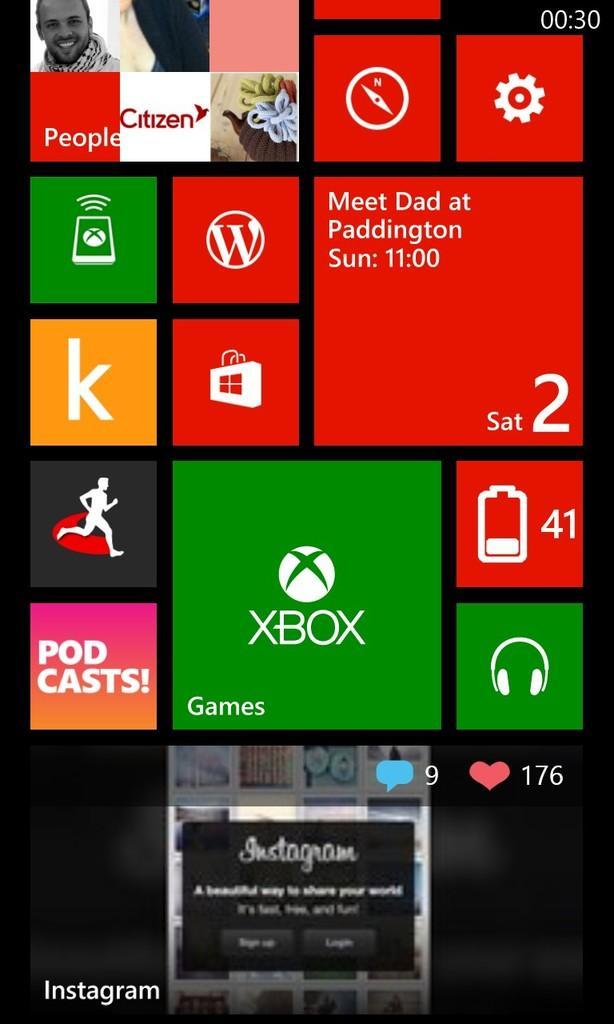In one or two sentences, can you explain what this image depicts? In this image I can see the screen of a mobile which is having different apps. At the bottom of the screen there is a instagram app and it represents there are 9 comments and 176 likes. At the right top corner it is showing time. 